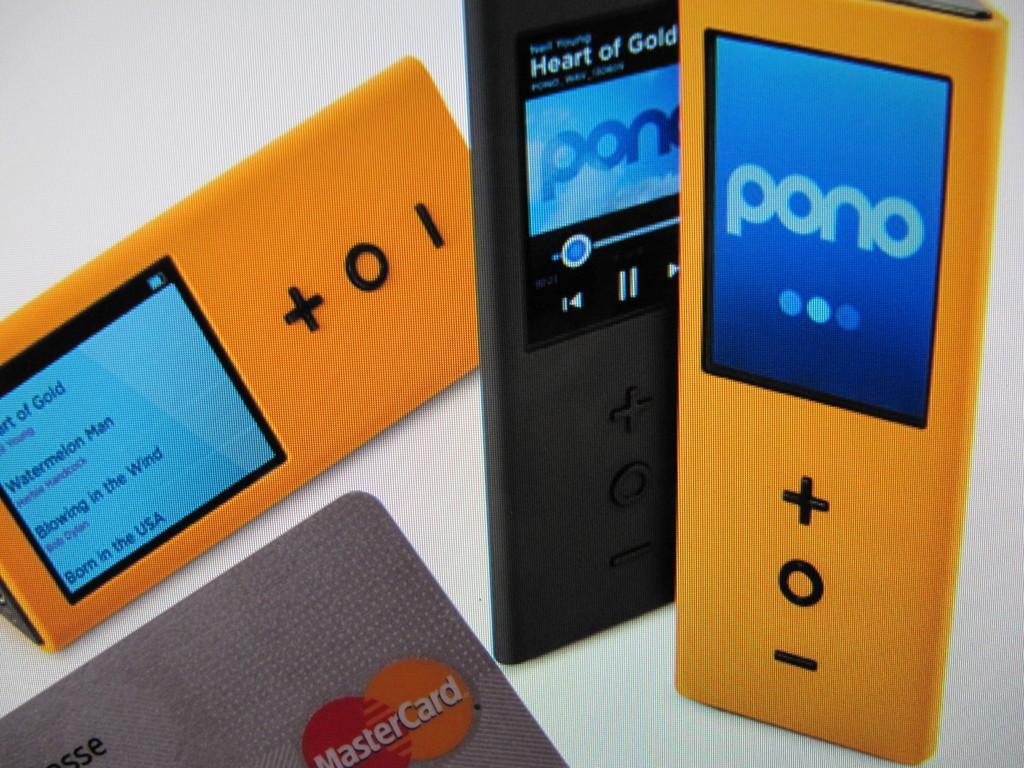Could you give a brief overview of what you see in this image? In this image I can see three airpods, they are in orange and black color. In front I can see a card and I can see white color background. 